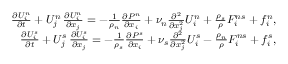<formula> <loc_0><loc_0><loc_500><loc_500>\begin{array} { r } { \frac { \partial U _ { i } ^ { n } } { \partial t } + U _ { j } ^ { n } \, \frac { \partial U _ { i } ^ { n } } { \partial x _ { j } } = - \frac { 1 } { \rho _ { n } } \frac { \partial P ^ { n } } { \partial x _ { i } } + \nu _ { n } \frac { \partial ^ { 2 } } { \partial x _ { j } ^ { 2 } } U _ { i } ^ { n } + \frac { \rho _ { s } } { \rho } F _ { i } ^ { n s } + f _ { i } ^ { n } , } \\ { \frac { \partial U _ { i } ^ { s } } { \partial t } + U _ { j } ^ { s } \, \frac { \partial U _ { i } ^ { s } } { \partial x _ { j } } = - \frac { 1 } { \rho _ { s } } \frac { \partial P ^ { s } } { \partial x _ { i } } + \nu _ { s } \frac { \partial ^ { 2 } } { \partial x _ { j } ^ { 2 } } U _ { i } ^ { s } - \frac { \rho _ { n } } { \rho } F _ { i } ^ { n s } + f _ { i } ^ { s } , } \end{array}</formula> 